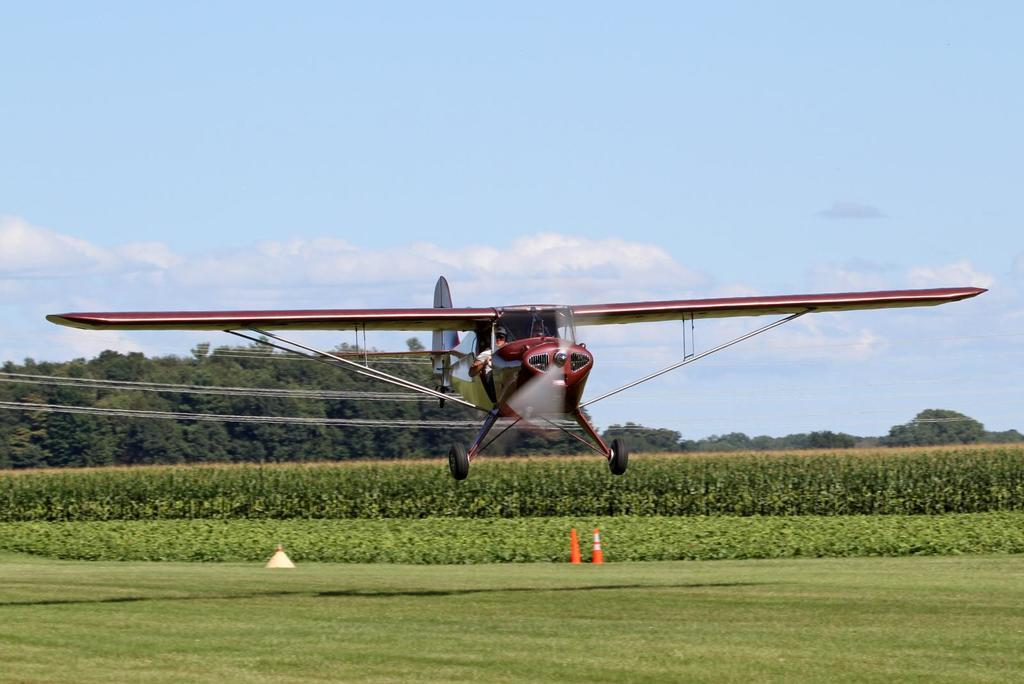What is the main subject in the air in the image? There is an airplane in the air in the image. What objects can be seen on the ground in the image? There are traffic cones on the grass in the image. What type of vegetation is visible in the image? There are plants visible in the image. What can be seen in the background of the image? There are trees and the sky visible in the background of the image. What is the condition of the sky in the image? Clouds are present in the sky in the image. What type of love can be seen between the airplane and the stranger in the image? There is no stranger present in the image, and therefore no interaction or love between the airplane and a stranger can be observed. 